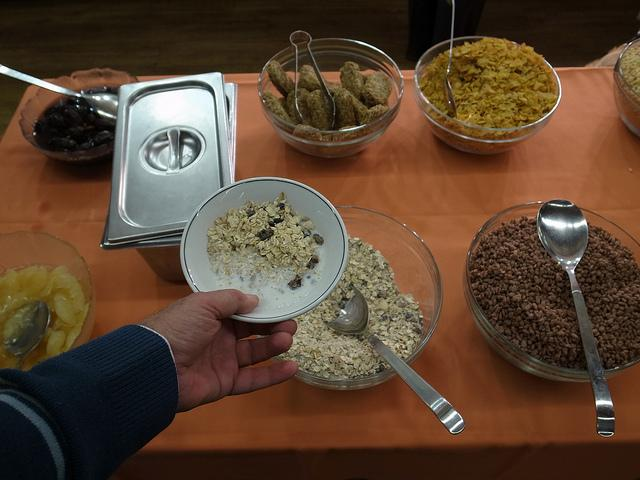What's most likely in the box? food 